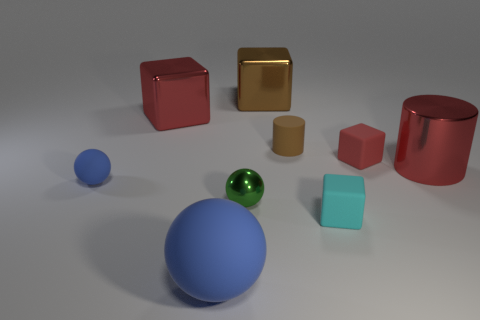What is the shape of the big shiny thing that is the same color as the shiny cylinder?
Offer a very short reply. Cube. Is there a small metal ball that has the same color as the big matte ball?
Ensure brevity in your answer.  No. Is the number of cyan matte objects that are on the left side of the tiny blue thing less than the number of red things that are to the right of the tiny green shiny sphere?
Give a very brief answer. Yes. What is the material of the big thing that is behind the tiny cyan matte cube and on the left side of the big brown object?
Ensure brevity in your answer.  Metal. There is a tiny green object; is its shape the same as the large red metal thing that is left of the large metallic cylinder?
Provide a short and direct response. No. How many other objects are there of the same size as the cyan thing?
Give a very brief answer. 4. Is the number of tiny rubber blocks greater than the number of small red rubber things?
Provide a succinct answer. Yes. What number of red blocks are behind the small brown rubber thing and right of the tiny brown matte object?
Give a very brief answer. 0. What shape is the big object in front of the big metal object that is to the right of the big shiny block that is right of the large matte ball?
Your answer should be compact. Sphere. Is there anything else that is the same shape as the large brown metal thing?
Make the answer very short. Yes. 